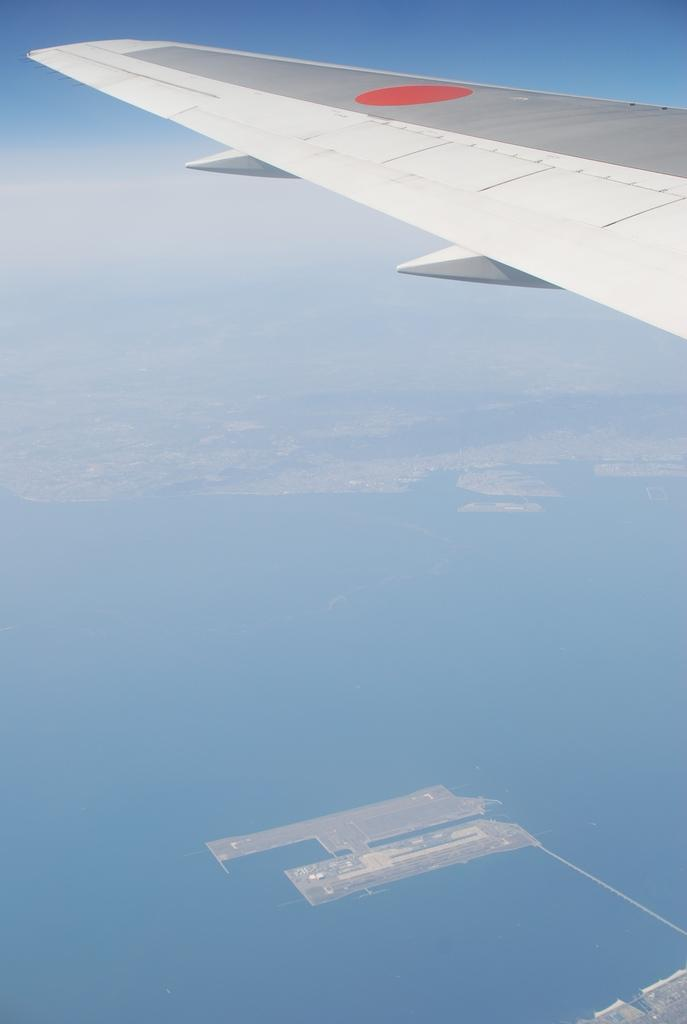What can be seen in the sky in the image? There is an aeroplane wing and clouds in the sky in the image. What is the perspective of the image? The image is a top view. What is visible below the sky in the image? There is water, buildings, and other objects visible in the image. What type of stew is being cooked on the aeroplane wing in the image? There is no stew present in the image; it features an aeroplane wing in a top view. Can you see any steam coming from the buildings or other objects in the image? There is no mention of steam in the image. 